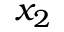<formula> <loc_0><loc_0><loc_500><loc_500>x _ { 2 }</formula> 